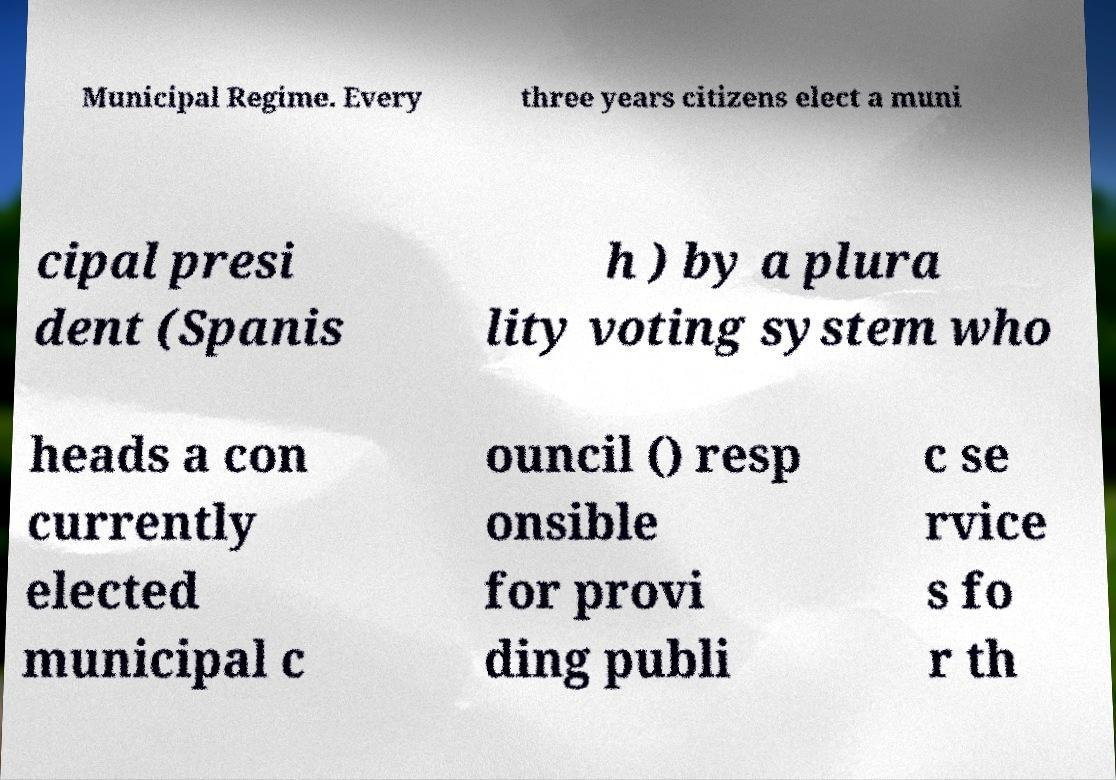Please read and relay the text visible in this image. What does it say? Municipal Regime. Every three years citizens elect a muni cipal presi dent (Spanis h ) by a plura lity voting system who heads a con currently elected municipal c ouncil () resp onsible for provi ding publi c se rvice s fo r th 